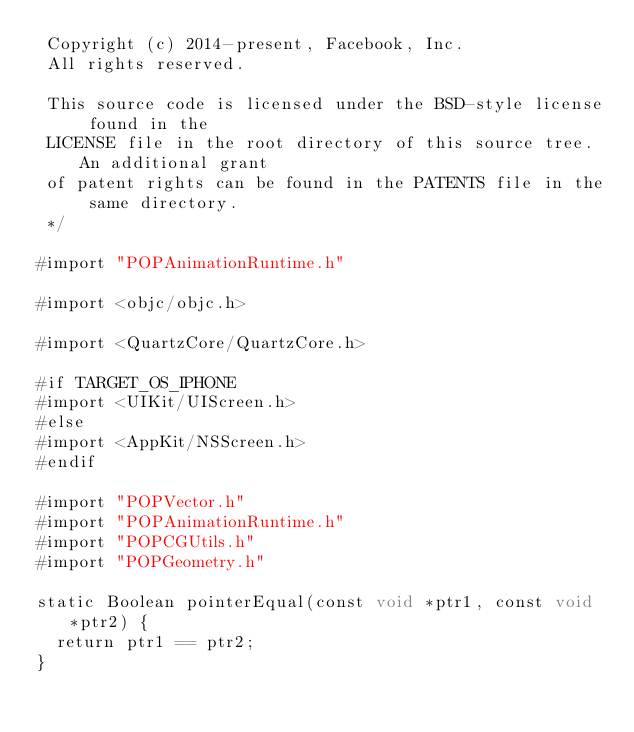<code> <loc_0><loc_0><loc_500><loc_500><_ObjectiveC_> Copyright (c) 2014-present, Facebook, Inc.
 All rights reserved.
 
 This source code is licensed under the BSD-style license found in the
 LICENSE file in the root directory of this source tree. An additional grant
 of patent rights can be found in the PATENTS file in the same directory.
 */

#import "POPAnimationRuntime.h"

#import <objc/objc.h>

#import <QuartzCore/QuartzCore.h>

#if TARGET_OS_IPHONE
#import <UIKit/UIScreen.h>
#else
#import <AppKit/NSScreen.h>
#endif

#import "POPVector.h"
#import "POPAnimationRuntime.h"
#import "POPCGUtils.h"
#import "POPGeometry.h"

static Boolean pointerEqual(const void *ptr1, const void *ptr2) {
  return ptr1 == ptr2;
}
</code> 